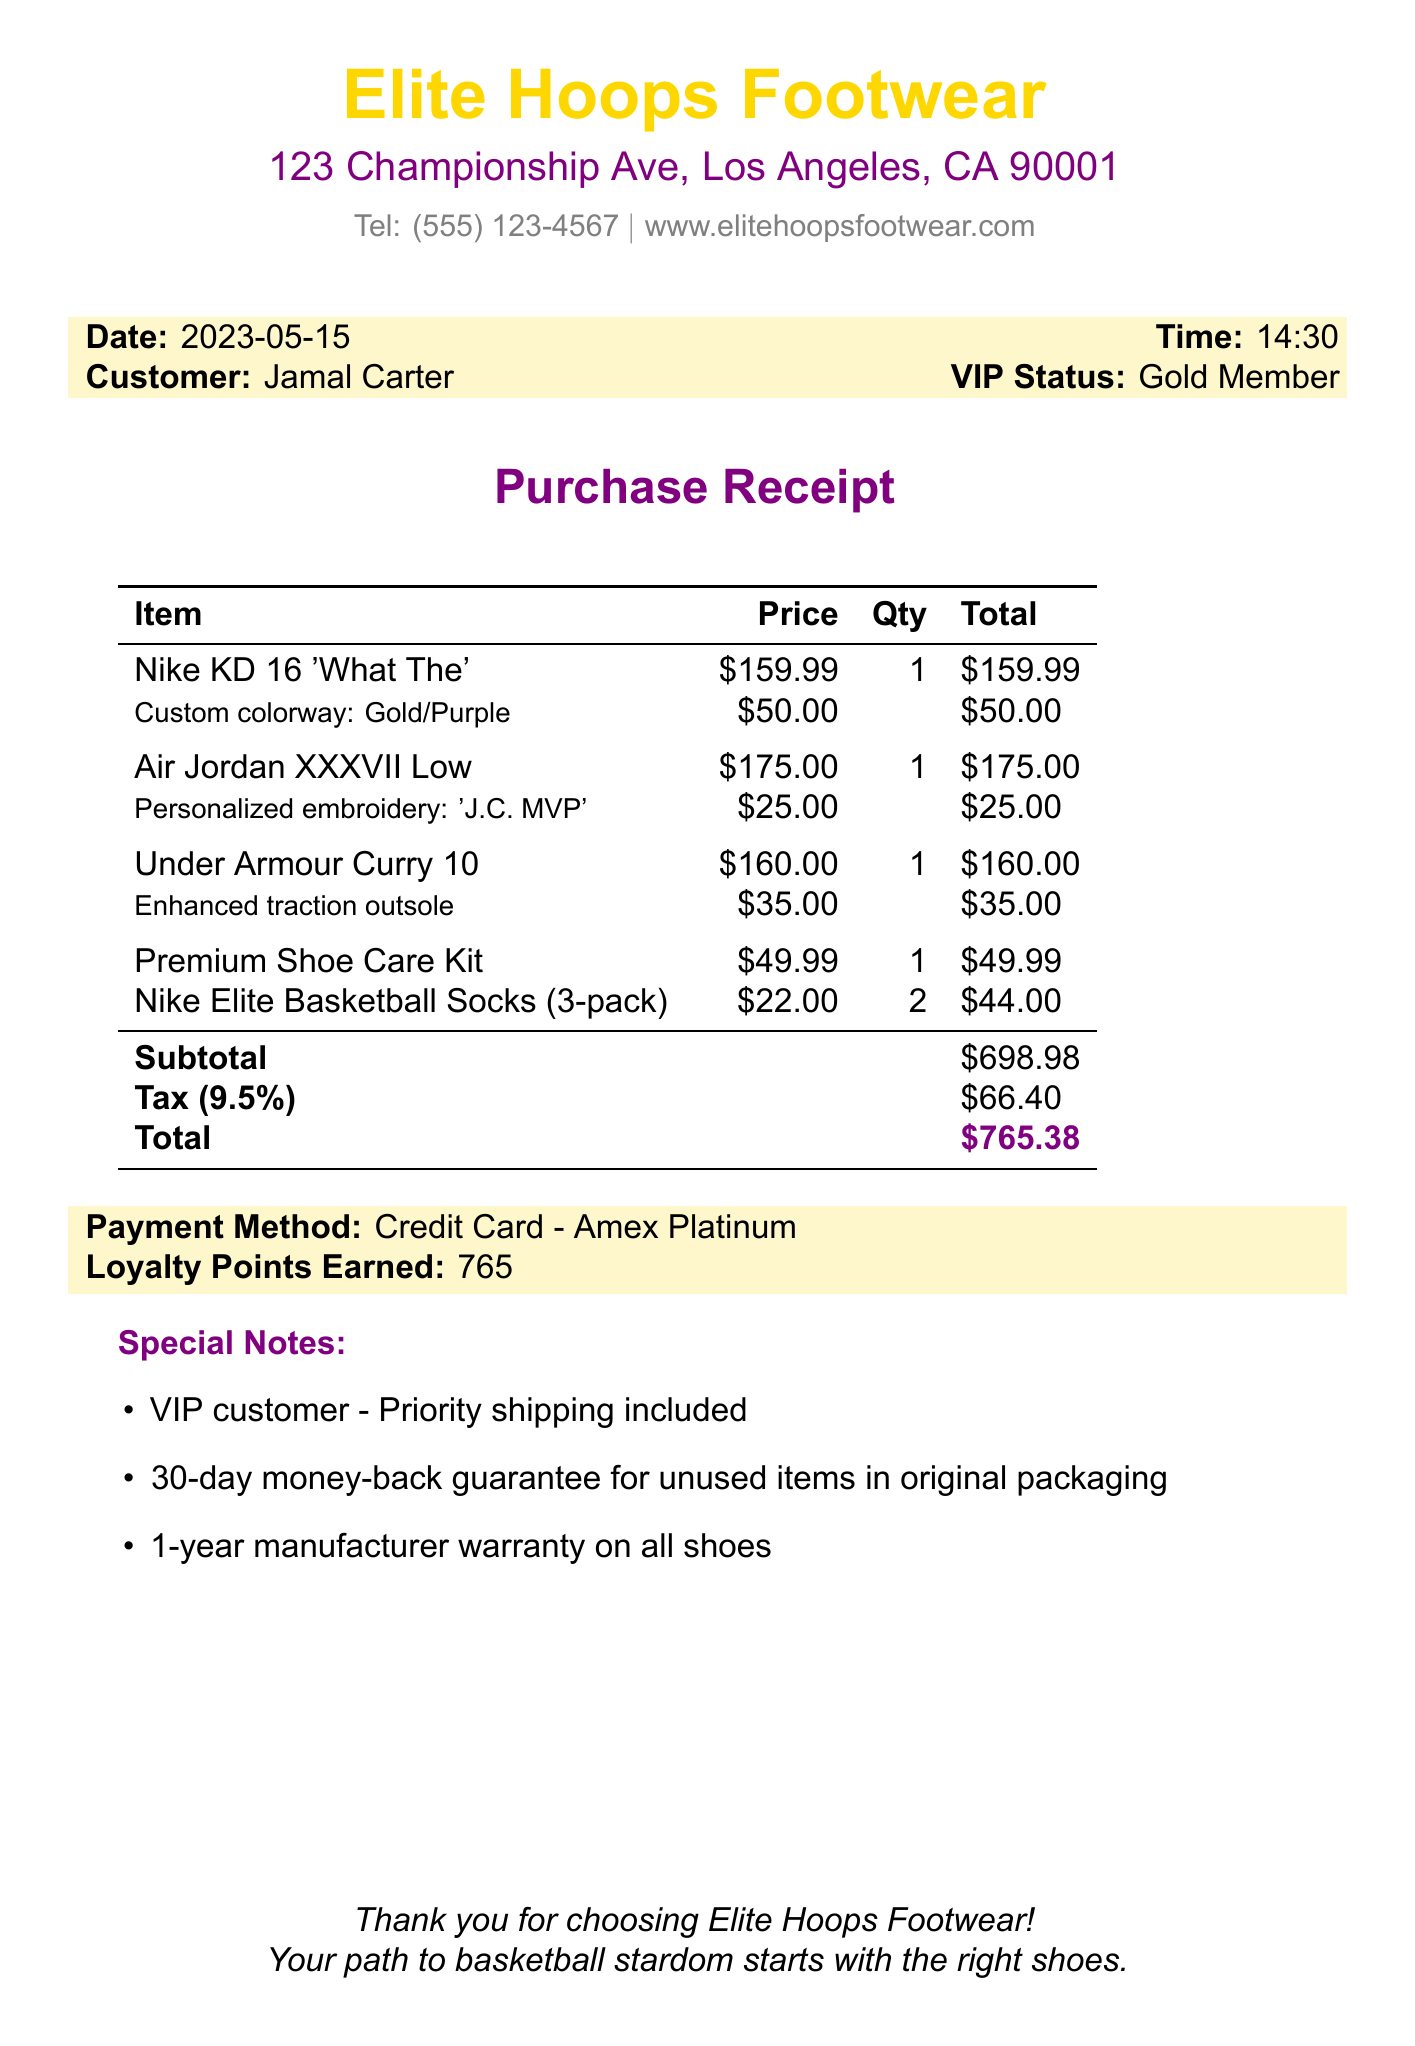What is the store name? The store name is prominently displayed at the top of the document.
Answer: Elite Hoops Footwear What is the total amount spent? The total amount is calculated and mentioned in the receipt under the total.
Answer: $765.38 What is the customization fee for the Nike KD 16? The customization fee is listed next to the item details for the Nike KD 16.
Answer: $50.00 How many loyalty points did Jamal earn? The loyalty points earned is mentioned towards the end of the document.
Answer: 765 What is the warranty period for shoes? The warranty details are provided in the special notes section of the receipt.
Answer: 1-year What date was the purchase made? The purchase date is indicated in the receipt's header section.
Answer: 2023-05-15 How many units of Nike Elite Basketball Socks were purchased? The quantity purchased is noted in the items section of the receipt.
Answer: 2 What is the tax rate applied to the purchase? The tax rate is stated in the subtotal section of the receipt.
Answer: 9.5% What is the payment method used? The payment method is clearly indicated in the payment details section.
Answer: Credit Card - Amex Platinum 